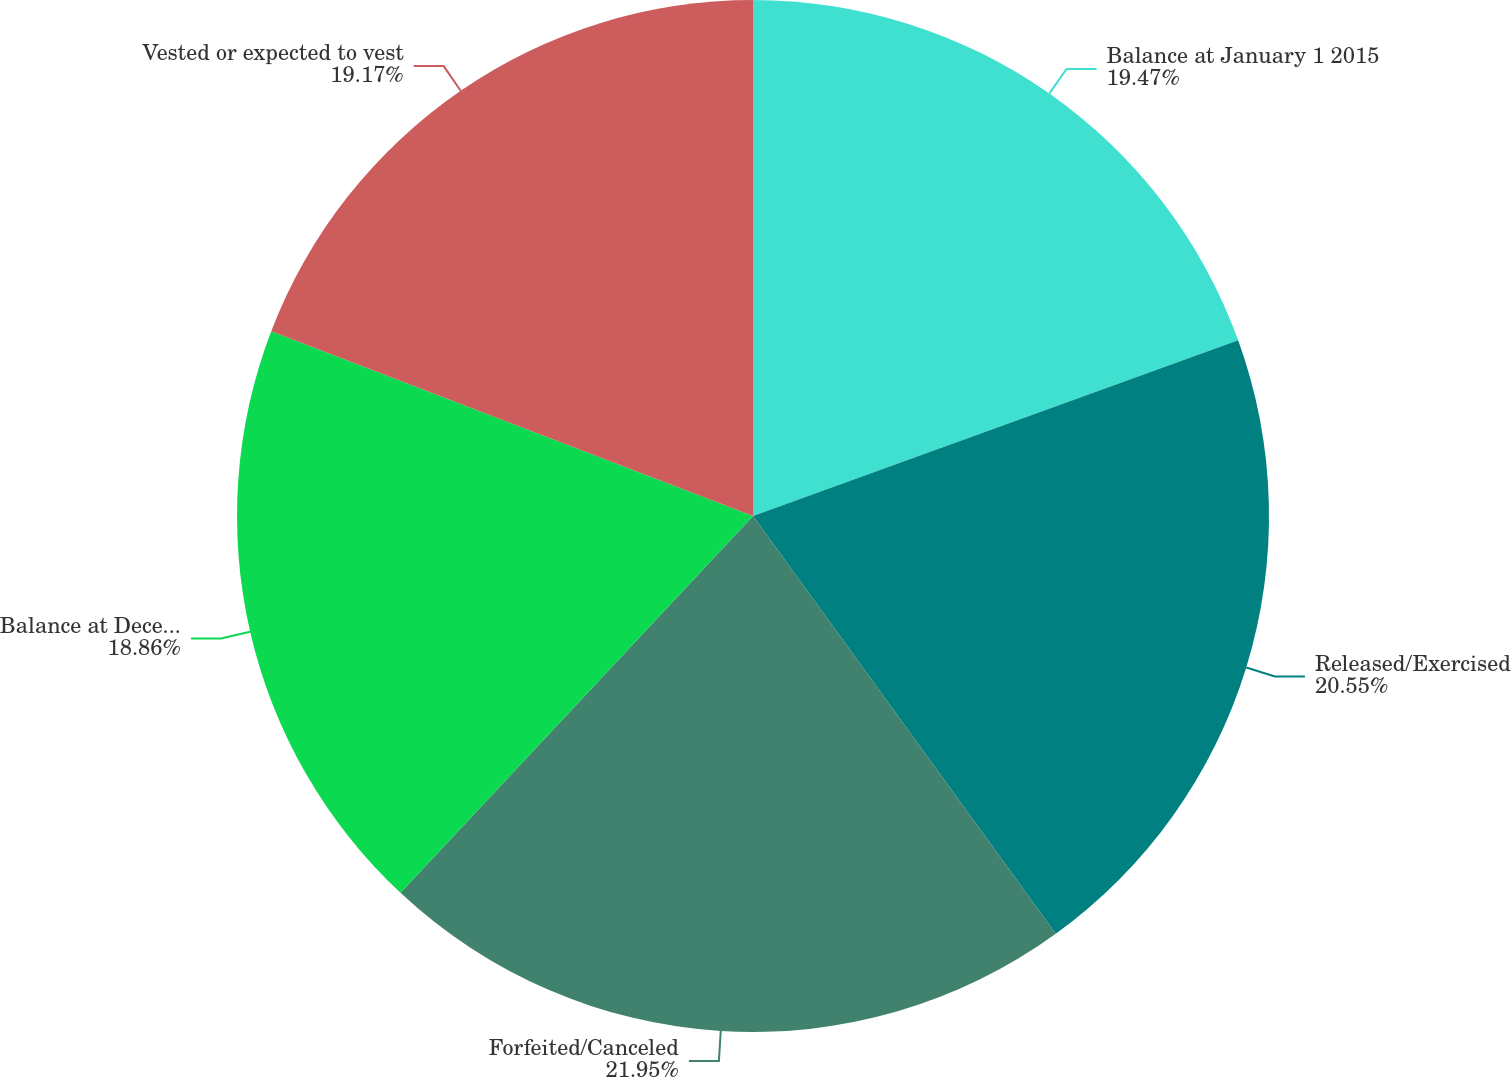Convert chart. <chart><loc_0><loc_0><loc_500><loc_500><pie_chart><fcel>Balance at January 1 2015<fcel>Released/Exercised<fcel>Forfeited/Canceled<fcel>Balance at December 31 2015<fcel>Vested or expected to vest<nl><fcel>19.47%<fcel>20.55%<fcel>21.95%<fcel>18.86%<fcel>19.17%<nl></chart> 